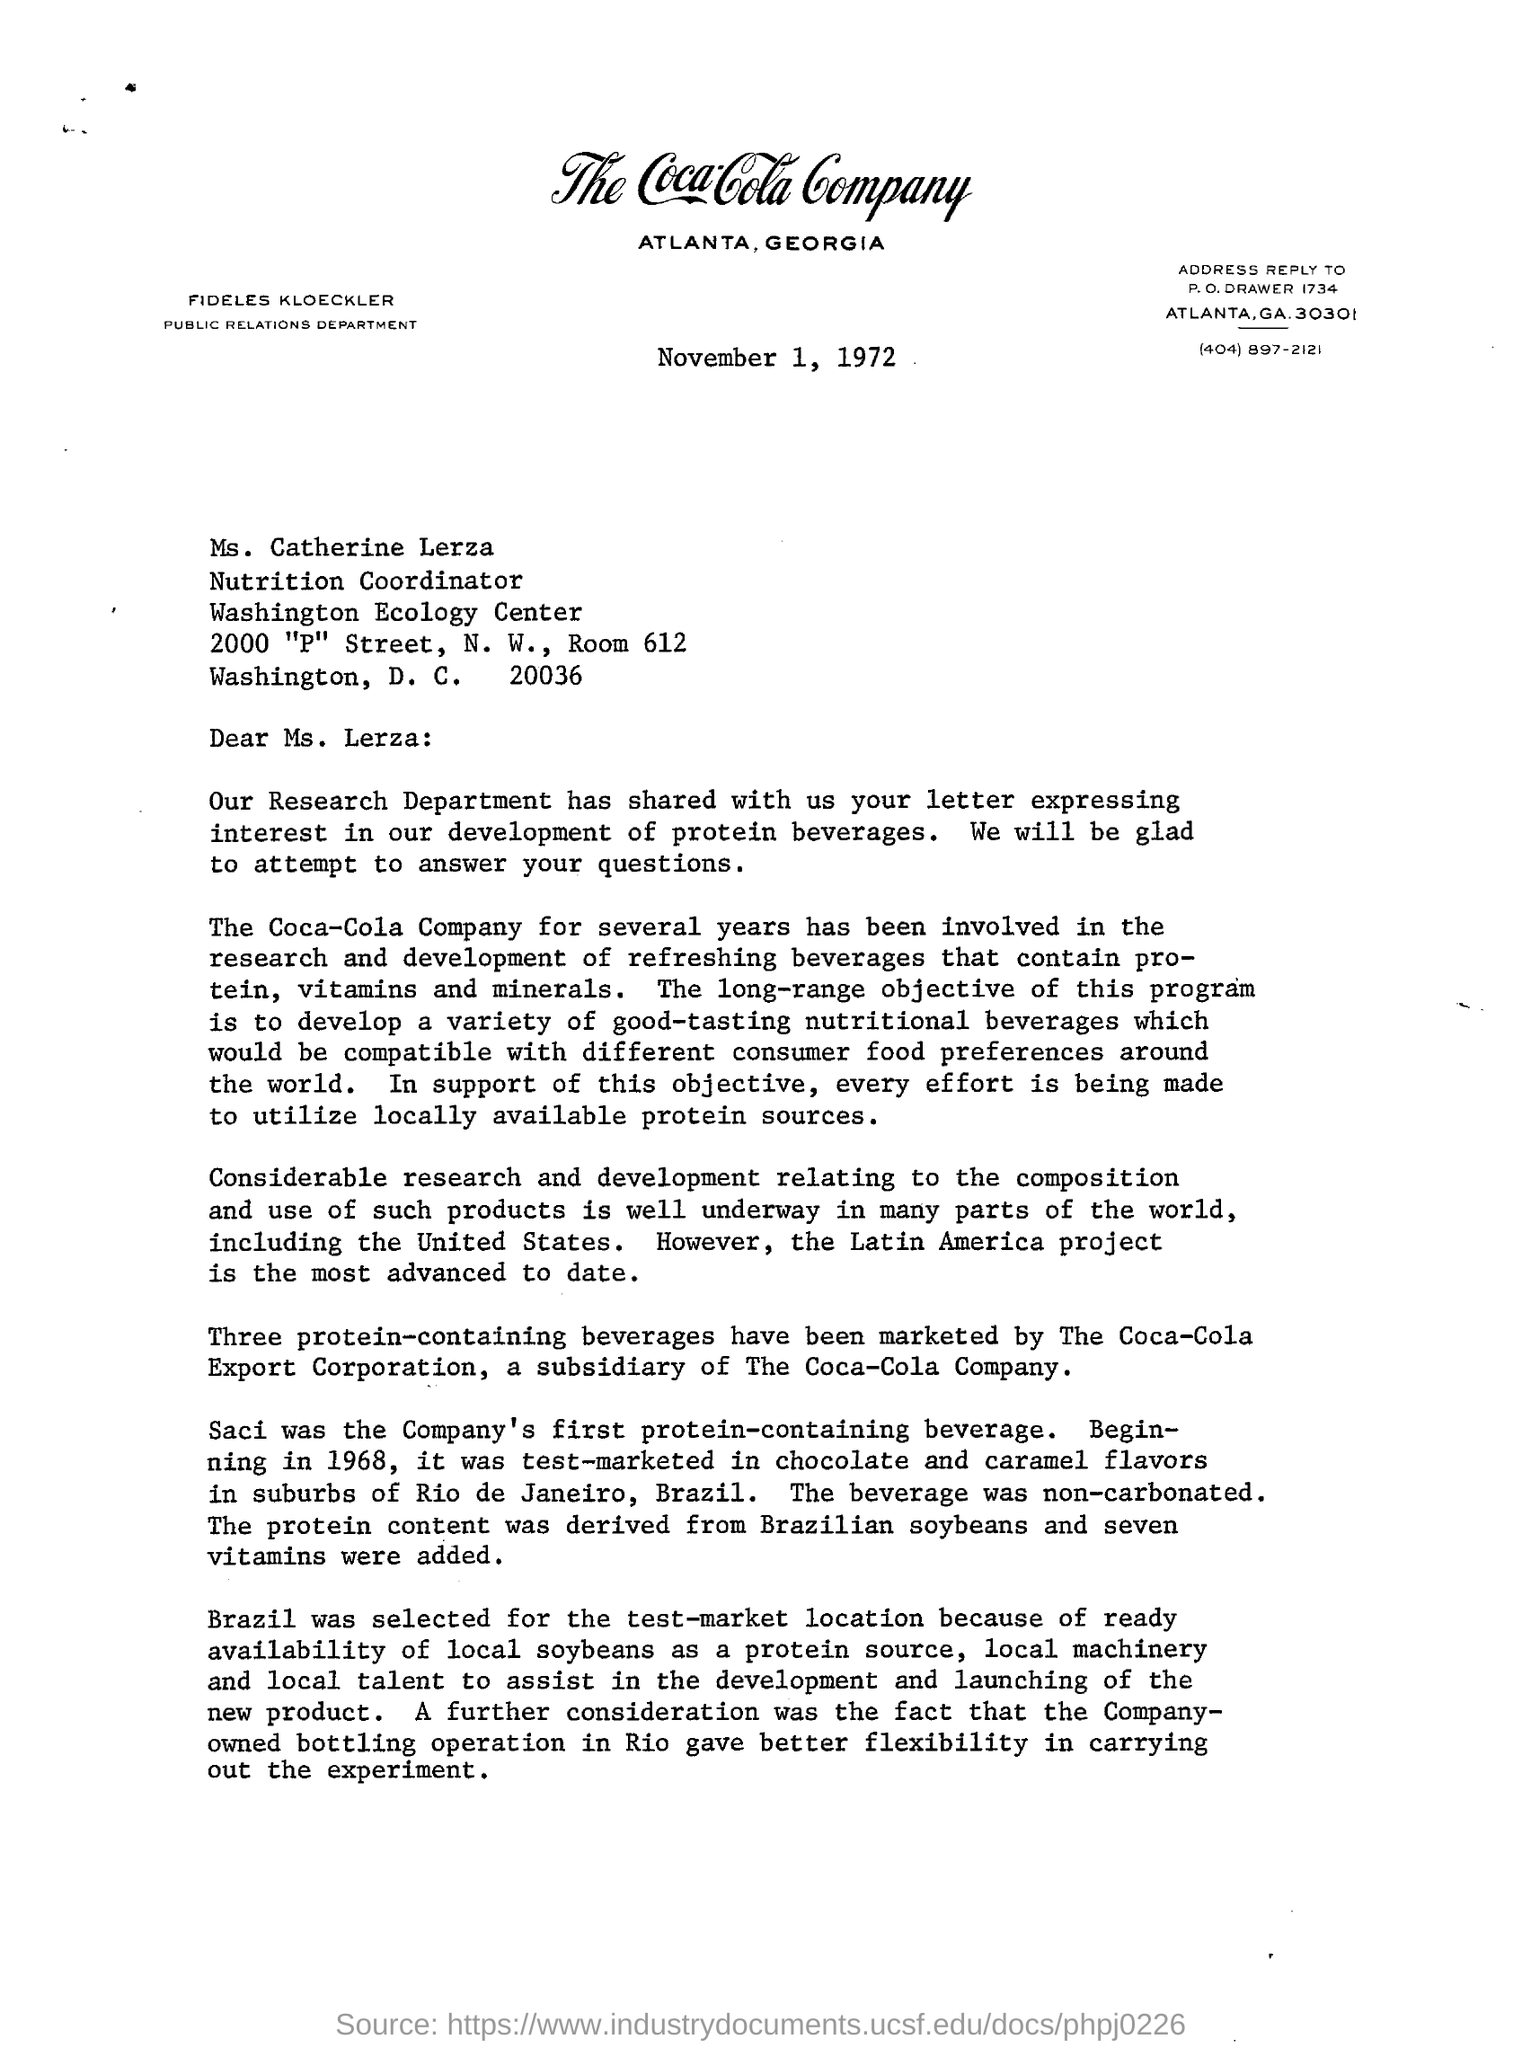Where is the place of coca-cola companyas  mentioned in the letterhead?
Ensure brevity in your answer.  Atlanta, Georgia. Who is this letter addressed to?
Provide a short and direct response. Ms. Lerza. What was the company's first protein containing beverage?
Your response must be concise. Saci. 